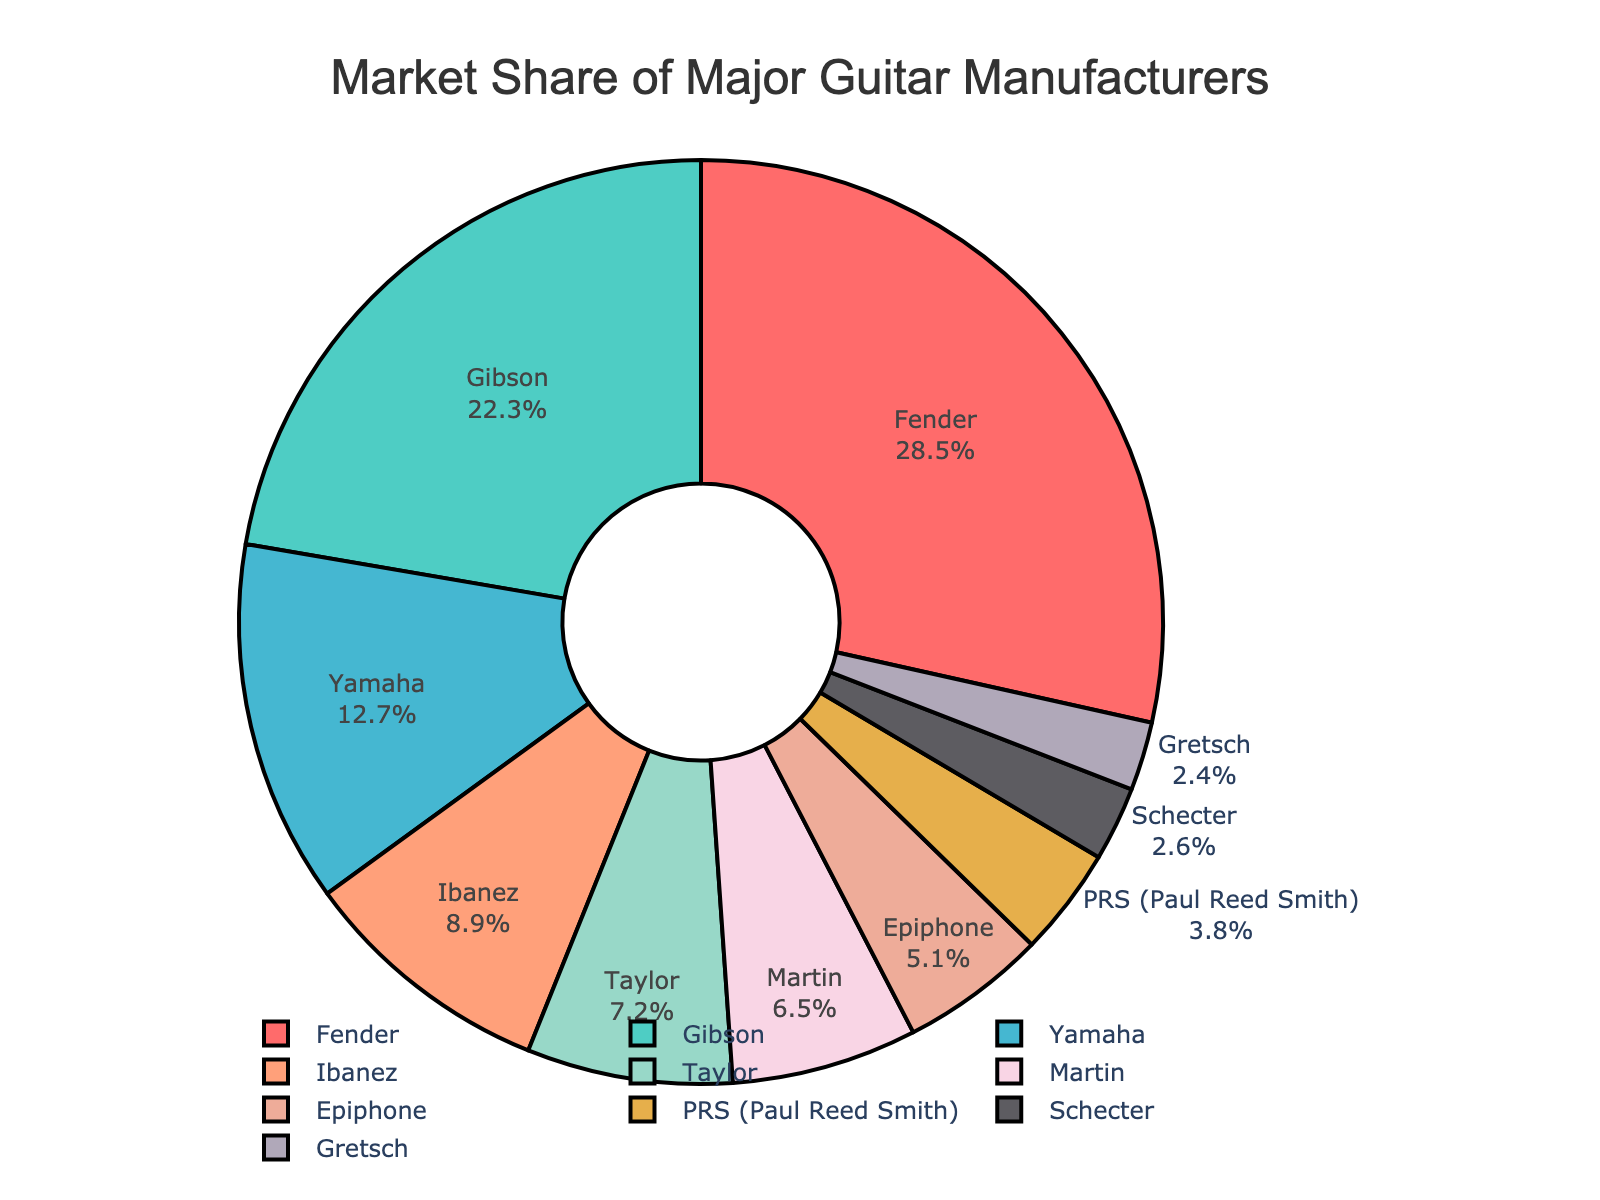What is the market share of Gibson? Look for Gibson in the pie chart and read the value associated with it.
Answer: 22.3% Which brand has the smallest market share and what is it? Identify the smallest segment in the pie chart and read the brand and its market share.
Answer: Gretsch, 2.4% What is the combined market share of Fender and Epiphone? Add the market shares of Fender and Epiphone: 28.5 + 5.1 = 33.6
Answer: 33.6% How much larger is Yamaha’s market share compared to Taylor’s? Subtract Taylor's market share from Yamaha's: 12.7 - 7.2 = 5.5
Answer: 5.5% What percentage of the market do PRS (Paul Reed Smith) and Schecter share together? Add the market shares of PRS (Paul Reed Smith) and Schecter: 3.8 + 2.6 = 6.4
Answer: 6.4% Which brands have a market share greater than 10%? Identify segments in the pie chart with market shares greater than 10%, which are Fender, Gibson, and Yamaha.
Answer: Fender, Gibson, Yamaha Compare the market shares of Ibanez and Taylor. Which is greater and by how much? Subtract Taylor's market share from Ibanez's: 8.9 - 7.2 = 1.7, Ibanez's market share is greater.
Answer: Ibanez, 1.7% If you sum the market shares of the top three brands, what is the result? Add the market shares of Fender, Gibson, and Yamaha: 28.5 + 22.3 + 12.7 = 63.5
Answer: 63.5% Which brand's segment is represented in light blue, and what is its market share? Identify the light blue segment in the pie chart and read the brand and its market share.
Answer: Ibanez, 8.9% What is the difference in market share between the highest and lowest market share brands? Subtract the smallest market share (Gretsch: 2.4%) from the largest market share (Fender: 28.5%): 28.5 - 2.4 = 26.1
Answer: 26.1 